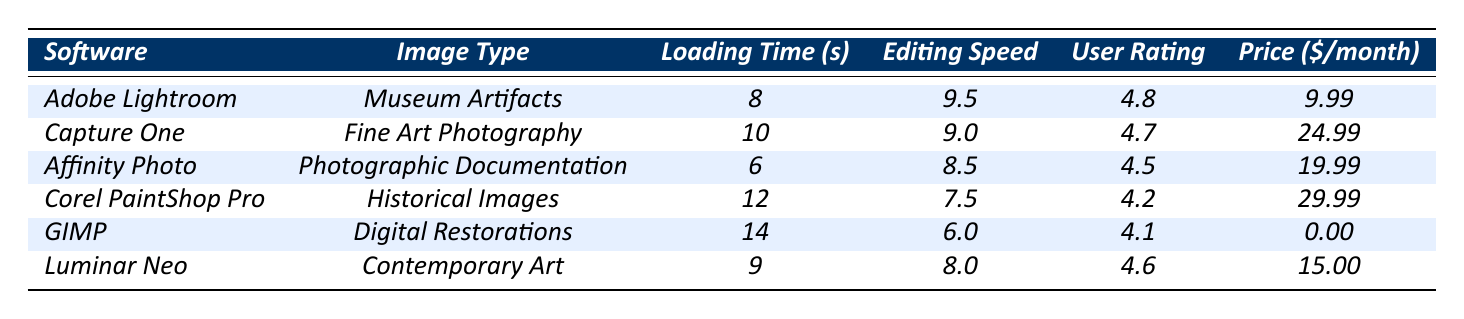What is the editing speed score of Affinity Photo? The table lists Affinity Photo's editing speed score directly under the "Editing Speed" column, which shows a value of 8.5.
Answer: 8.5 Which software has the lowest user rating? By reviewing the "User Rating" column, Corel PaintShop Pro shows the lowest score of 4.2 compared to the others.
Answer: Corel PaintShop Pro What is the loading time difference between GIMP and Adobe Lightroom? GIMP has a loading time of 14 seconds, while Adobe Lightroom has a loading time of 8 seconds. The difference is 14 - 8 = 6 seconds.
Answer: 6 seconds Which software provides the most features for museum-related images? Analyzing the features listed, Adobe Lightroom offers three features: Color Correction, Noise Reduction, and Batch Processing. This is more than the other software options for museum-related images.
Answer: Adobe Lightroom What is the average user rating of all the listed software? The user ratings are as follows: 4.8, 4.7, 4.5, 4.2, 4.1, and 4.6. Summing these gives 28.9, and dividing by 6 (the number of software) gives an average rating of 4.8.
Answer: 4.8 Is Luminar Neo more affordable than Corel PaintShop Pro? Luminar Neo has a monthly price of $15.00, while Corel PaintShop Pro costs $29.99. Since $15.00 is less than $29.99, Luminar Neo is more affordable.
Answer: Yes Which software has the highest loading time, and what is it? The "Loading Time (s)" column shows GIMP with the highest value of 14 seconds, making it the slowest in loading time.
Answer: GIMP, 14 seconds If you were to choose the software based solely on the best editing speed score, which would it be? The highest editing speed score in the table is 9.5 for Adobe Lightroom. Therefore, it ranks as the best based on that criterion.
Answer: Adobe Lightroom What is the price range of the software listed in the table? The prices per month range from $0.00 (GIMP) to $29.99 (Corel PaintShop Pro). Therefore, the range is $0.00 to $29.99.
Answer: $0.00 to $29.99 How many software options offer a price below $20 per month? Reviewing the prices, Affinity Photo ($19.99), Luminar Neo ($15.00), and Adobe Lightroom ($9.99) are below $20. This makes a total of three software options.
Answer: 3 Which software is tailored for "Digital Restorations," and what score does it have for editing speed? GIMP is explicitly listed under the "Digital Restorations" image type and has an editing speed score of 6.0.
Answer: GIMP, 6.0 